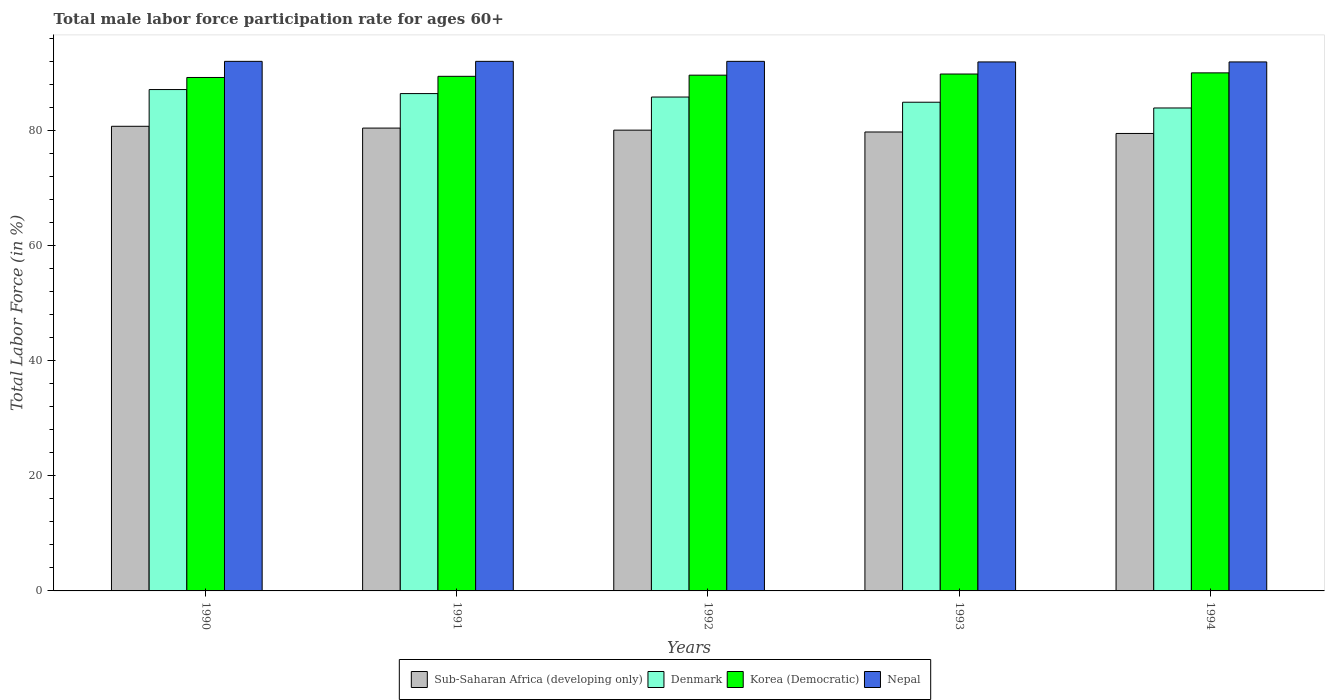How many bars are there on the 2nd tick from the left?
Provide a succinct answer. 4. What is the label of the 3rd group of bars from the left?
Your response must be concise. 1992. What is the male labor force participation rate in Nepal in 1990?
Keep it short and to the point. 92. Across all years, what is the maximum male labor force participation rate in Nepal?
Your answer should be compact. 92. Across all years, what is the minimum male labor force participation rate in Denmark?
Keep it short and to the point. 83.9. In which year was the male labor force participation rate in Nepal minimum?
Provide a short and direct response. 1993. What is the total male labor force participation rate in Korea (Democratic) in the graph?
Provide a short and direct response. 448. What is the difference between the male labor force participation rate in Sub-Saharan Africa (developing only) in 1992 and that in 1994?
Your response must be concise. 0.58. What is the difference between the male labor force participation rate in Korea (Democratic) in 1993 and the male labor force participation rate in Denmark in 1990?
Make the answer very short. 2.7. What is the average male labor force participation rate in Sub-Saharan Africa (developing only) per year?
Your answer should be very brief. 80.07. In the year 1994, what is the difference between the male labor force participation rate in Nepal and male labor force participation rate in Denmark?
Your response must be concise. 8. In how many years, is the male labor force participation rate in Korea (Democratic) greater than 36 %?
Provide a short and direct response. 5. What is the ratio of the male labor force participation rate in Sub-Saharan Africa (developing only) in 1990 to that in 1992?
Your response must be concise. 1.01. Is the male labor force participation rate in Denmark in 1992 less than that in 1993?
Provide a succinct answer. No. Is the difference between the male labor force participation rate in Nepal in 1991 and 1993 greater than the difference between the male labor force participation rate in Denmark in 1991 and 1993?
Provide a succinct answer. No. What is the difference between the highest and the second highest male labor force participation rate in Korea (Democratic)?
Keep it short and to the point. 0.2. What is the difference between the highest and the lowest male labor force participation rate in Denmark?
Provide a succinct answer. 3.2. Is it the case that in every year, the sum of the male labor force participation rate in Sub-Saharan Africa (developing only) and male labor force participation rate in Korea (Democratic) is greater than the sum of male labor force participation rate in Nepal and male labor force participation rate in Denmark?
Keep it short and to the point. No. What does the 1st bar from the left in 1994 represents?
Give a very brief answer. Sub-Saharan Africa (developing only). What does the 2nd bar from the right in 1991 represents?
Provide a succinct answer. Korea (Democratic). How many years are there in the graph?
Keep it short and to the point. 5. How are the legend labels stacked?
Provide a short and direct response. Horizontal. What is the title of the graph?
Your answer should be compact. Total male labor force participation rate for ages 60+. What is the label or title of the Y-axis?
Offer a terse response. Total Labor Force (in %). What is the Total Labor Force (in %) in Sub-Saharan Africa (developing only) in 1990?
Your answer should be compact. 80.72. What is the Total Labor Force (in %) of Denmark in 1990?
Make the answer very short. 87.1. What is the Total Labor Force (in %) of Korea (Democratic) in 1990?
Keep it short and to the point. 89.2. What is the Total Labor Force (in %) of Nepal in 1990?
Your response must be concise. 92. What is the Total Labor Force (in %) in Sub-Saharan Africa (developing only) in 1991?
Ensure brevity in your answer.  80.41. What is the Total Labor Force (in %) of Denmark in 1991?
Make the answer very short. 86.4. What is the Total Labor Force (in %) of Korea (Democratic) in 1991?
Make the answer very short. 89.4. What is the Total Labor Force (in %) in Nepal in 1991?
Provide a short and direct response. 92. What is the Total Labor Force (in %) in Sub-Saharan Africa (developing only) in 1992?
Make the answer very short. 80.05. What is the Total Labor Force (in %) in Denmark in 1992?
Give a very brief answer. 85.8. What is the Total Labor Force (in %) of Korea (Democratic) in 1992?
Your response must be concise. 89.6. What is the Total Labor Force (in %) in Nepal in 1992?
Provide a succinct answer. 92. What is the Total Labor Force (in %) of Sub-Saharan Africa (developing only) in 1993?
Your answer should be very brief. 79.73. What is the Total Labor Force (in %) in Denmark in 1993?
Provide a succinct answer. 84.9. What is the Total Labor Force (in %) in Korea (Democratic) in 1993?
Provide a short and direct response. 89.8. What is the Total Labor Force (in %) in Nepal in 1993?
Provide a succinct answer. 91.9. What is the Total Labor Force (in %) in Sub-Saharan Africa (developing only) in 1994?
Your answer should be very brief. 79.47. What is the Total Labor Force (in %) in Denmark in 1994?
Give a very brief answer. 83.9. What is the Total Labor Force (in %) in Korea (Democratic) in 1994?
Your response must be concise. 90. What is the Total Labor Force (in %) of Nepal in 1994?
Your answer should be compact. 91.9. Across all years, what is the maximum Total Labor Force (in %) in Sub-Saharan Africa (developing only)?
Offer a terse response. 80.72. Across all years, what is the maximum Total Labor Force (in %) in Denmark?
Offer a terse response. 87.1. Across all years, what is the maximum Total Labor Force (in %) in Nepal?
Provide a short and direct response. 92. Across all years, what is the minimum Total Labor Force (in %) in Sub-Saharan Africa (developing only)?
Offer a very short reply. 79.47. Across all years, what is the minimum Total Labor Force (in %) of Denmark?
Your answer should be very brief. 83.9. Across all years, what is the minimum Total Labor Force (in %) in Korea (Democratic)?
Your answer should be compact. 89.2. Across all years, what is the minimum Total Labor Force (in %) of Nepal?
Your answer should be very brief. 91.9. What is the total Total Labor Force (in %) of Sub-Saharan Africa (developing only) in the graph?
Offer a very short reply. 400.37. What is the total Total Labor Force (in %) of Denmark in the graph?
Offer a terse response. 428.1. What is the total Total Labor Force (in %) of Korea (Democratic) in the graph?
Provide a short and direct response. 448. What is the total Total Labor Force (in %) of Nepal in the graph?
Your answer should be very brief. 459.8. What is the difference between the Total Labor Force (in %) in Sub-Saharan Africa (developing only) in 1990 and that in 1991?
Offer a terse response. 0.31. What is the difference between the Total Labor Force (in %) of Denmark in 1990 and that in 1991?
Your answer should be very brief. 0.7. What is the difference between the Total Labor Force (in %) of Korea (Democratic) in 1990 and that in 1991?
Your answer should be very brief. -0.2. What is the difference between the Total Labor Force (in %) in Nepal in 1990 and that in 1991?
Make the answer very short. 0. What is the difference between the Total Labor Force (in %) of Sub-Saharan Africa (developing only) in 1990 and that in 1992?
Provide a succinct answer. 0.67. What is the difference between the Total Labor Force (in %) in Denmark in 1990 and that in 1992?
Offer a very short reply. 1.3. What is the difference between the Total Labor Force (in %) in Korea (Democratic) in 1990 and that in 1992?
Offer a very short reply. -0.4. What is the difference between the Total Labor Force (in %) of Denmark in 1990 and that in 1993?
Keep it short and to the point. 2.2. What is the difference between the Total Labor Force (in %) of Sub-Saharan Africa (developing only) in 1990 and that in 1994?
Provide a short and direct response. 1.25. What is the difference between the Total Labor Force (in %) in Sub-Saharan Africa (developing only) in 1991 and that in 1992?
Provide a short and direct response. 0.36. What is the difference between the Total Labor Force (in %) in Denmark in 1991 and that in 1992?
Ensure brevity in your answer.  0.6. What is the difference between the Total Labor Force (in %) in Nepal in 1991 and that in 1992?
Your response must be concise. 0. What is the difference between the Total Labor Force (in %) of Sub-Saharan Africa (developing only) in 1991 and that in 1993?
Keep it short and to the point. 0.68. What is the difference between the Total Labor Force (in %) of Sub-Saharan Africa (developing only) in 1991 and that in 1994?
Make the answer very short. 0.93. What is the difference between the Total Labor Force (in %) of Korea (Democratic) in 1991 and that in 1994?
Offer a very short reply. -0.6. What is the difference between the Total Labor Force (in %) of Nepal in 1991 and that in 1994?
Provide a succinct answer. 0.1. What is the difference between the Total Labor Force (in %) in Sub-Saharan Africa (developing only) in 1992 and that in 1993?
Your answer should be compact. 0.32. What is the difference between the Total Labor Force (in %) of Denmark in 1992 and that in 1993?
Your answer should be very brief. 0.9. What is the difference between the Total Labor Force (in %) in Korea (Democratic) in 1992 and that in 1993?
Provide a succinct answer. -0.2. What is the difference between the Total Labor Force (in %) in Nepal in 1992 and that in 1993?
Give a very brief answer. 0.1. What is the difference between the Total Labor Force (in %) in Sub-Saharan Africa (developing only) in 1992 and that in 1994?
Keep it short and to the point. 0.58. What is the difference between the Total Labor Force (in %) in Denmark in 1992 and that in 1994?
Offer a terse response. 1.9. What is the difference between the Total Labor Force (in %) of Korea (Democratic) in 1992 and that in 1994?
Offer a terse response. -0.4. What is the difference between the Total Labor Force (in %) in Nepal in 1992 and that in 1994?
Provide a succinct answer. 0.1. What is the difference between the Total Labor Force (in %) in Sub-Saharan Africa (developing only) in 1993 and that in 1994?
Provide a succinct answer. 0.26. What is the difference between the Total Labor Force (in %) of Denmark in 1993 and that in 1994?
Your answer should be very brief. 1. What is the difference between the Total Labor Force (in %) in Korea (Democratic) in 1993 and that in 1994?
Give a very brief answer. -0.2. What is the difference between the Total Labor Force (in %) of Sub-Saharan Africa (developing only) in 1990 and the Total Labor Force (in %) of Denmark in 1991?
Offer a very short reply. -5.68. What is the difference between the Total Labor Force (in %) in Sub-Saharan Africa (developing only) in 1990 and the Total Labor Force (in %) in Korea (Democratic) in 1991?
Ensure brevity in your answer.  -8.68. What is the difference between the Total Labor Force (in %) in Sub-Saharan Africa (developing only) in 1990 and the Total Labor Force (in %) in Nepal in 1991?
Provide a short and direct response. -11.28. What is the difference between the Total Labor Force (in %) in Denmark in 1990 and the Total Labor Force (in %) in Korea (Democratic) in 1991?
Your response must be concise. -2.3. What is the difference between the Total Labor Force (in %) of Denmark in 1990 and the Total Labor Force (in %) of Nepal in 1991?
Offer a very short reply. -4.9. What is the difference between the Total Labor Force (in %) of Sub-Saharan Africa (developing only) in 1990 and the Total Labor Force (in %) of Denmark in 1992?
Make the answer very short. -5.08. What is the difference between the Total Labor Force (in %) of Sub-Saharan Africa (developing only) in 1990 and the Total Labor Force (in %) of Korea (Democratic) in 1992?
Your answer should be very brief. -8.88. What is the difference between the Total Labor Force (in %) of Sub-Saharan Africa (developing only) in 1990 and the Total Labor Force (in %) of Nepal in 1992?
Your answer should be compact. -11.28. What is the difference between the Total Labor Force (in %) of Denmark in 1990 and the Total Labor Force (in %) of Korea (Democratic) in 1992?
Give a very brief answer. -2.5. What is the difference between the Total Labor Force (in %) of Korea (Democratic) in 1990 and the Total Labor Force (in %) of Nepal in 1992?
Ensure brevity in your answer.  -2.8. What is the difference between the Total Labor Force (in %) in Sub-Saharan Africa (developing only) in 1990 and the Total Labor Force (in %) in Denmark in 1993?
Your answer should be very brief. -4.18. What is the difference between the Total Labor Force (in %) of Sub-Saharan Africa (developing only) in 1990 and the Total Labor Force (in %) of Korea (Democratic) in 1993?
Offer a very short reply. -9.08. What is the difference between the Total Labor Force (in %) in Sub-Saharan Africa (developing only) in 1990 and the Total Labor Force (in %) in Nepal in 1993?
Provide a succinct answer. -11.18. What is the difference between the Total Labor Force (in %) of Denmark in 1990 and the Total Labor Force (in %) of Nepal in 1993?
Ensure brevity in your answer.  -4.8. What is the difference between the Total Labor Force (in %) of Sub-Saharan Africa (developing only) in 1990 and the Total Labor Force (in %) of Denmark in 1994?
Offer a terse response. -3.18. What is the difference between the Total Labor Force (in %) in Sub-Saharan Africa (developing only) in 1990 and the Total Labor Force (in %) in Korea (Democratic) in 1994?
Your answer should be very brief. -9.28. What is the difference between the Total Labor Force (in %) in Sub-Saharan Africa (developing only) in 1990 and the Total Labor Force (in %) in Nepal in 1994?
Provide a short and direct response. -11.18. What is the difference between the Total Labor Force (in %) of Denmark in 1990 and the Total Labor Force (in %) of Korea (Democratic) in 1994?
Ensure brevity in your answer.  -2.9. What is the difference between the Total Labor Force (in %) of Denmark in 1990 and the Total Labor Force (in %) of Nepal in 1994?
Your answer should be compact. -4.8. What is the difference between the Total Labor Force (in %) in Sub-Saharan Africa (developing only) in 1991 and the Total Labor Force (in %) in Denmark in 1992?
Your answer should be very brief. -5.39. What is the difference between the Total Labor Force (in %) of Sub-Saharan Africa (developing only) in 1991 and the Total Labor Force (in %) of Korea (Democratic) in 1992?
Provide a short and direct response. -9.19. What is the difference between the Total Labor Force (in %) in Sub-Saharan Africa (developing only) in 1991 and the Total Labor Force (in %) in Nepal in 1992?
Your response must be concise. -11.59. What is the difference between the Total Labor Force (in %) of Denmark in 1991 and the Total Labor Force (in %) of Korea (Democratic) in 1992?
Make the answer very short. -3.2. What is the difference between the Total Labor Force (in %) in Sub-Saharan Africa (developing only) in 1991 and the Total Labor Force (in %) in Denmark in 1993?
Your answer should be very brief. -4.49. What is the difference between the Total Labor Force (in %) in Sub-Saharan Africa (developing only) in 1991 and the Total Labor Force (in %) in Korea (Democratic) in 1993?
Offer a terse response. -9.39. What is the difference between the Total Labor Force (in %) of Sub-Saharan Africa (developing only) in 1991 and the Total Labor Force (in %) of Nepal in 1993?
Your response must be concise. -11.49. What is the difference between the Total Labor Force (in %) in Korea (Democratic) in 1991 and the Total Labor Force (in %) in Nepal in 1993?
Your response must be concise. -2.5. What is the difference between the Total Labor Force (in %) in Sub-Saharan Africa (developing only) in 1991 and the Total Labor Force (in %) in Denmark in 1994?
Offer a very short reply. -3.49. What is the difference between the Total Labor Force (in %) in Sub-Saharan Africa (developing only) in 1991 and the Total Labor Force (in %) in Korea (Democratic) in 1994?
Your answer should be very brief. -9.59. What is the difference between the Total Labor Force (in %) of Sub-Saharan Africa (developing only) in 1991 and the Total Labor Force (in %) of Nepal in 1994?
Your answer should be compact. -11.49. What is the difference between the Total Labor Force (in %) in Sub-Saharan Africa (developing only) in 1992 and the Total Labor Force (in %) in Denmark in 1993?
Your answer should be compact. -4.85. What is the difference between the Total Labor Force (in %) in Sub-Saharan Africa (developing only) in 1992 and the Total Labor Force (in %) in Korea (Democratic) in 1993?
Your response must be concise. -9.75. What is the difference between the Total Labor Force (in %) in Sub-Saharan Africa (developing only) in 1992 and the Total Labor Force (in %) in Nepal in 1993?
Provide a succinct answer. -11.85. What is the difference between the Total Labor Force (in %) in Denmark in 1992 and the Total Labor Force (in %) in Nepal in 1993?
Provide a succinct answer. -6.1. What is the difference between the Total Labor Force (in %) in Korea (Democratic) in 1992 and the Total Labor Force (in %) in Nepal in 1993?
Give a very brief answer. -2.3. What is the difference between the Total Labor Force (in %) of Sub-Saharan Africa (developing only) in 1992 and the Total Labor Force (in %) of Denmark in 1994?
Keep it short and to the point. -3.85. What is the difference between the Total Labor Force (in %) of Sub-Saharan Africa (developing only) in 1992 and the Total Labor Force (in %) of Korea (Democratic) in 1994?
Make the answer very short. -9.95. What is the difference between the Total Labor Force (in %) of Sub-Saharan Africa (developing only) in 1992 and the Total Labor Force (in %) of Nepal in 1994?
Offer a terse response. -11.85. What is the difference between the Total Labor Force (in %) in Denmark in 1992 and the Total Labor Force (in %) in Nepal in 1994?
Give a very brief answer. -6.1. What is the difference between the Total Labor Force (in %) in Korea (Democratic) in 1992 and the Total Labor Force (in %) in Nepal in 1994?
Your answer should be compact. -2.3. What is the difference between the Total Labor Force (in %) of Sub-Saharan Africa (developing only) in 1993 and the Total Labor Force (in %) of Denmark in 1994?
Provide a succinct answer. -4.17. What is the difference between the Total Labor Force (in %) in Sub-Saharan Africa (developing only) in 1993 and the Total Labor Force (in %) in Korea (Democratic) in 1994?
Offer a very short reply. -10.27. What is the difference between the Total Labor Force (in %) of Sub-Saharan Africa (developing only) in 1993 and the Total Labor Force (in %) of Nepal in 1994?
Offer a terse response. -12.17. What is the difference between the Total Labor Force (in %) of Denmark in 1993 and the Total Labor Force (in %) of Korea (Democratic) in 1994?
Your answer should be very brief. -5.1. What is the difference between the Total Labor Force (in %) of Denmark in 1993 and the Total Labor Force (in %) of Nepal in 1994?
Provide a short and direct response. -7. What is the difference between the Total Labor Force (in %) of Korea (Democratic) in 1993 and the Total Labor Force (in %) of Nepal in 1994?
Make the answer very short. -2.1. What is the average Total Labor Force (in %) in Sub-Saharan Africa (developing only) per year?
Offer a terse response. 80.07. What is the average Total Labor Force (in %) in Denmark per year?
Your answer should be compact. 85.62. What is the average Total Labor Force (in %) of Korea (Democratic) per year?
Your answer should be very brief. 89.6. What is the average Total Labor Force (in %) of Nepal per year?
Offer a terse response. 91.96. In the year 1990, what is the difference between the Total Labor Force (in %) in Sub-Saharan Africa (developing only) and Total Labor Force (in %) in Denmark?
Ensure brevity in your answer.  -6.38. In the year 1990, what is the difference between the Total Labor Force (in %) in Sub-Saharan Africa (developing only) and Total Labor Force (in %) in Korea (Democratic)?
Make the answer very short. -8.48. In the year 1990, what is the difference between the Total Labor Force (in %) in Sub-Saharan Africa (developing only) and Total Labor Force (in %) in Nepal?
Ensure brevity in your answer.  -11.28. In the year 1990, what is the difference between the Total Labor Force (in %) in Denmark and Total Labor Force (in %) in Korea (Democratic)?
Provide a short and direct response. -2.1. In the year 1990, what is the difference between the Total Labor Force (in %) in Denmark and Total Labor Force (in %) in Nepal?
Your answer should be compact. -4.9. In the year 1991, what is the difference between the Total Labor Force (in %) in Sub-Saharan Africa (developing only) and Total Labor Force (in %) in Denmark?
Provide a succinct answer. -5.99. In the year 1991, what is the difference between the Total Labor Force (in %) of Sub-Saharan Africa (developing only) and Total Labor Force (in %) of Korea (Democratic)?
Make the answer very short. -8.99. In the year 1991, what is the difference between the Total Labor Force (in %) in Sub-Saharan Africa (developing only) and Total Labor Force (in %) in Nepal?
Keep it short and to the point. -11.59. In the year 1991, what is the difference between the Total Labor Force (in %) of Denmark and Total Labor Force (in %) of Korea (Democratic)?
Your answer should be very brief. -3. In the year 1991, what is the difference between the Total Labor Force (in %) in Denmark and Total Labor Force (in %) in Nepal?
Your response must be concise. -5.6. In the year 1992, what is the difference between the Total Labor Force (in %) of Sub-Saharan Africa (developing only) and Total Labor Force (in %) of Denmark?
Offer a terse response. -5.75. In the year 1992, what is the difference between the Total Labor Force (in %) in Sub-Saharan Africa (developing only) and Total Labor Force (in %) in Korea (Democratic)?
Your response must be concise. -9.55. In the year 1992, what is the difference between the Total Labor Force (in %) of Sub-Saharan Africa (developing only) and Total Labor Force (in %) of Nepal?
Provide a succinct answer. -11.95. In the year 1992, what is the difference between the Total Labor Force (in %) of Denmark and Total Labor Force (in %) of Korea (Democratic)?
Your answer should be very brief. -3.8. In the year 1992, what is the difference between the Total Labor Force (in %) of Denmark and Total Labor Force (in %) of Nepal?
Ensure brevity in your answer.  -6.2. In the year 1993, what is the difference between the Total Labor Force (in %) of Sub-Saharan Africa (developing only) and Total Labor Force (in %) of Denmark?
Give a very brief answer. -5.17. In the year 1993, what is the difference between the Total Labor Force (in %) in Sub-Saharan Africa (developing only) and Total Labor Force (in %) in Korea (Democratic)?
Give a very brief answer. -10.07. In the year 1993, what is the difference between the Total Labor Force (in %) in Sub-Saharan Africa (developing only) and Total Labor Force (in %) in Nepal?
Provide a short and direct response. -12.17. In the year 1993, what is the difference between the Total Labor Force (in %) in Korea (Democratic) and Total Labor Force (in %) in Nepal?
Your response must be concise. -2.1. In the year 1994, what is the difference between the Total Labor Force (in %) in Sub-Saharan Africa (developing only) and Total Labor Force (in %) in Denmark?
Offer a terse response. -4.43. In the year 1994, what is the difference between the Total Labor Force (in %) in Sub-Saharan Africa (developing only) and Total Labor Force (in %) in Korea (Democratic)?
Offer a very short reply. -10.53. In the year 1994, what is the difference between the Total Labor Force (in %) in Sub-Saharan Africa (developing only) and Total Labor Force (in %) in Nepal?
Offer a very short reply. -12.43. In the year 1994, what is the difference between the Total Labor Force (in %) in Denmark and Total Labor Force (in %) in Korea (Democratic)?
Provide a short and direct response. -6.1. In the year 1994, what is the difference between the Total Labor Force (in %) of Denmark and Total Labor Force (in %) of Nepal?
Your response must be concise. -8. What is the ratio of the Total Labor Force (in %) in Sub-Saharan Africa (developing only) in 1990 to that in 1991?
Your answer should be compact. 1. What is the ratio of the Total Labor Force (in %) in Denmark in 1990 to that in 1991?
Offer a terse response. 1.01. What is the ratio of the Total Labor Force (in %) in Sub-Saharan Africa (developing only) in 1990 to that in 1992?
Your response must be concise. 1.01. What is the ratio of the Total Labor Force (in %) of Denmark in 1990 to that in 1992?
Provide a succinct answer. 1.02. What is the ratio of the Total Labor Force (in %) in Korea (Democratic) in 1990 to that in 1992?
Your answer should be very brief. 1. What is the ratio of the Total Labor Force (in %) of Nepal in 1990 to that in 1992?
Offer a very short reply. 1. What is the ratio of the Total Labor Force (in %) of Sub-Saharan Africa (developing only) in 1990 to that in 1993?
Ensure brevity in your answer.  1.01. What is the ratio of the Total Labor Force (in %) in Denmark in 1990 to that in 1993?
Keep it short and to the point. 1.03. What is the ratio of the Total Labor Force (in %) of Korea (Democratic) in 1990 to that in 1993?
Your answer should be compact. 0.99. What is the ratio of the Total Labor Force (in %) of Sub-Saharan Africa (developing only) in 1990 to that in 1994?
Give a very brief answer. 1.02. What is the ratio of the Total Labor Force (in %) of Denmark in 1990 to that in 1994?
Ensure brevity in your answer.  1.04. What is the ratio of the Total Labor Force (in %) in Nepal in 1990 to that in 1994?
Your response must be concise. 1. What is the ratio of the Total Labor Force (in %) of Korea (Democratic) in 1991 to that in 1992?
Provide a short and direct response. 1. What is the ratio of the Total Labor Force (in %) of Nepal in 1991 to that in 1992?
Offer a terse response. 1. What is the ratio of the Total Labor Force (in %) in Sub-Saharan Africa (developing only) in 1991 to that in 1993?
Keep it short and to the point. 1.01. What is the ratio of the Total Labor Force (in %) in Denmark in 1991 to that in 1993?
Offer a terse response. 1.02. What is the ratio of the Total Labor Force (in %) in Korea (Democratic) in 1991 to that in 1993?
Give a very brief answer. 1. What is the ratio of the Total Labor Force (in %) in Sub-Saharan Africa (developing only) in 1991 to that in 1994?
Offer a terse response. 1.01. What is the ratio of the Total Labor Force (in %) in Denmark in 1991 to that in 1994?
Your answer should be very brief. 1.03. What is the ratio of the Total Labor Force (in %) of Sub-Saharan Africa (developing only) in 1992 to that in 1993?
Provide a succinct answer. 1. What is the ratio of the Total Labor Force (in %) in Denmark in 1992 to that in 1993?
Your answer should be very brief. 1.01. What is the ratio of the Total Labor Force (in %) of Sub-Saharan Africa (developing only) in 1992 to that in 1994?
Your answer should be compact. 1.01. What is the ratio of the Total Labor Force (in %) of Denmark in 1992 to that in 1994?
Offer a terse response. 1.02. What is the ratio of the Total Labor Force (in %) in Korea (Democratic) in 1992 to that in 1994?
Make the answer very short. 1. What is the ratio of the Total Labor Force (in %) in Sub-Saharan Africa (developing only) in 1993 to that in 1994?
Provide a succinct answer. 1. What is the ratio of the Total Labor Force (in %) in Denmark in 1993 to that in 1994?
Give a very brief answer. 1.01. What is the difference between the highest and the second highest Total Labor Force (in %) in Sub-Saharan Africa (developing only)?
Your answer should be compact. 0.31. What is the difference between the highest and the second highest Total Labor Force (in %) of Korea (Democratic)?
Offer a very short reply. 0.2. What is the difference between the highest and the second highest Total Labor Force (in %) of Nepal?
Your answer should be compact. 0. What is the difference between the highest and the lowest Total Labor Force (in %) in Sub-Saharan Africa (developing only)?
Keep it short and to the point. 1.25. What is the difference between the highest and the lowest Total Labor Force (in %) in Denmark?
Your answer should be compact. 3.2. What is the difference between the highest and the lowest Total Labor Force (in %) in Korea (Democratic)?
Offer a terse response. 0.8. What is the difference between the highest and the lowest Total Labor Force (in %) in Nepal?
Ensure brevity in your answer.  0.1. 